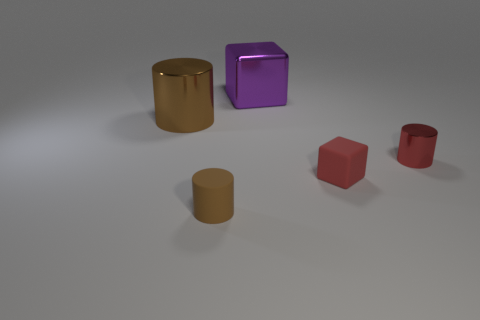Subtract all metal cylinders. How many cylinders are left? 1 Subtract 2 cylinders. How many cylinders are left? 1 Subtract all red cylinders. How many cylinders are left? 2 Add 5 purple objects. How many objects exist? 10 Subtract 0 green balls. How many objects are left? 5 Subtract all blocks. How many objects are left? 3 Subtract all blue cubes. Subtract all yellow balls. How many cubes are left? 2 Subtract all brown blocks. How many brown cylinders are left? 2 Subtract all red shiny things. Subtract all tiny blocks. How many objects are left? 3 Add 3 brown metal cylinders. How many brown metal cylinders are left? 4 